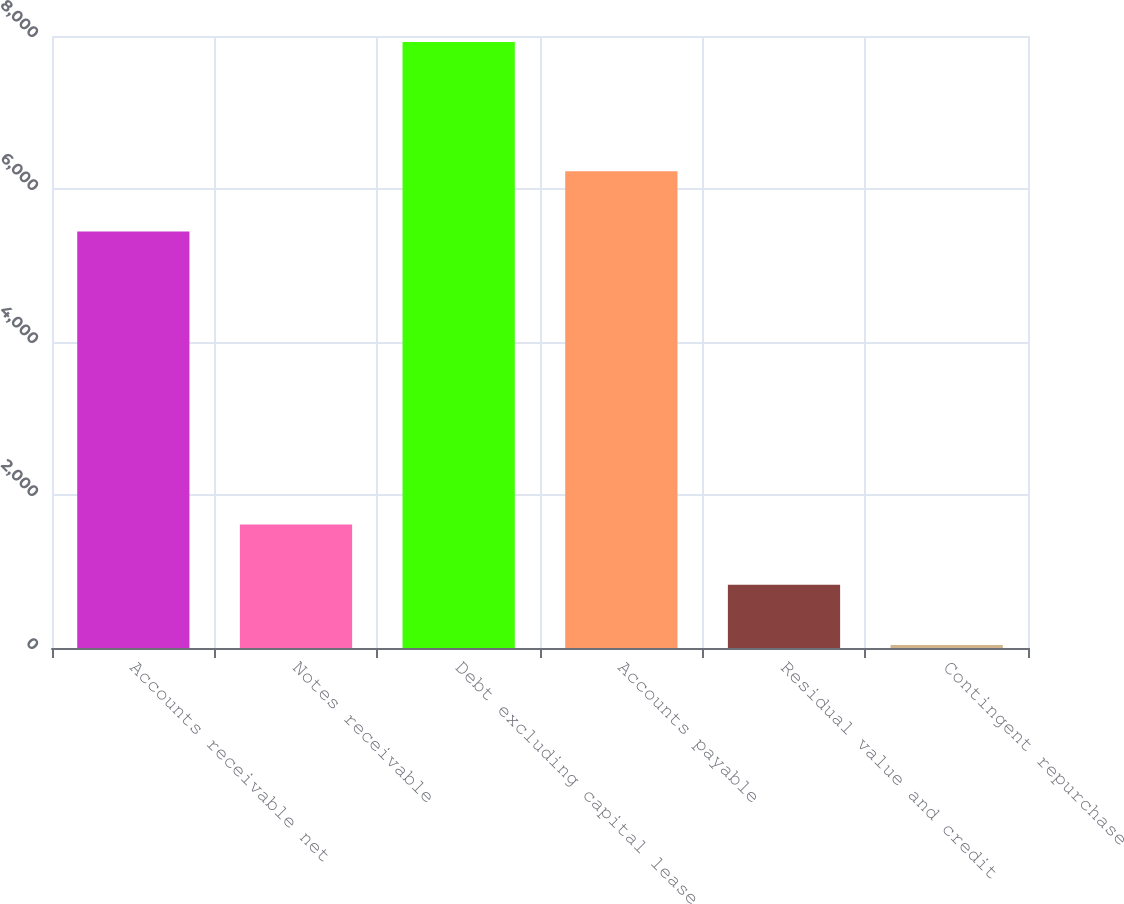Convert chart. <chart><loc_0><loc_0><loc_500><loc_500><bar_chart><fcel>Accounts receivable net<fcel>Notes receivable<fcel>Debt excluding capital lease<fcel>Accounts payable<fcel>Residual value and credit<fcel>Contingent repurchase<nl><fcel>5443<fcel>1615<fcel>7923<fcel>6231.5<fcel>826.5<fcel>38<nl></chart> 